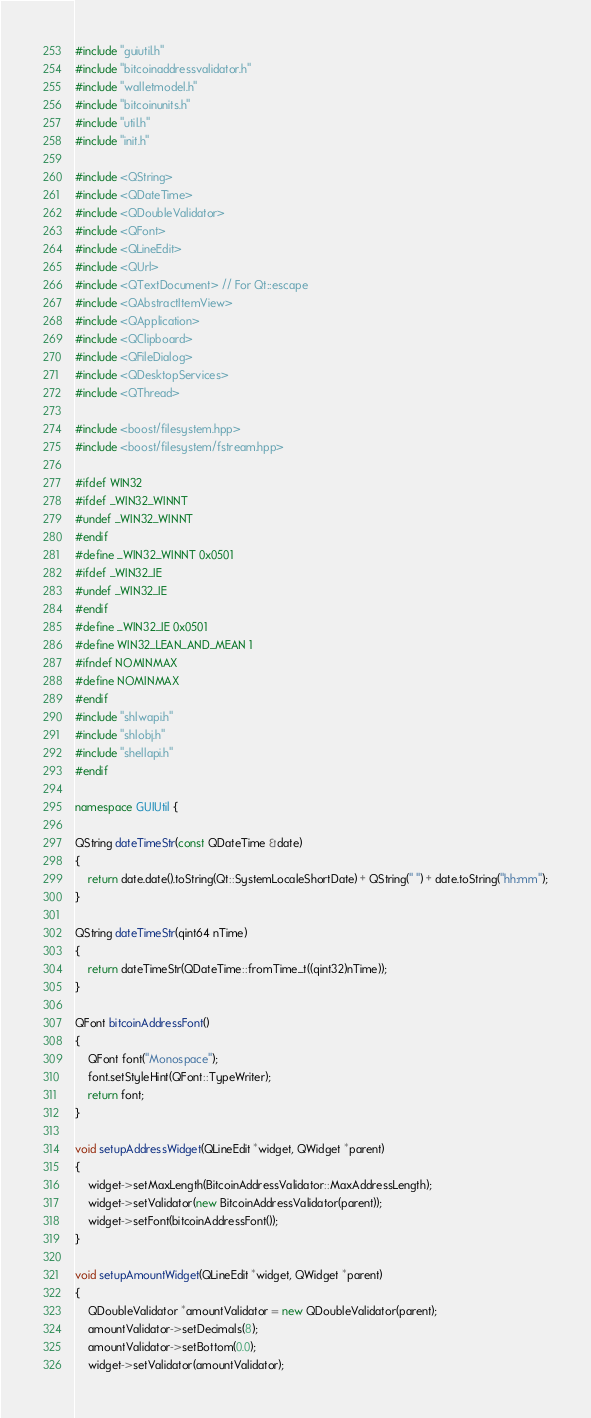Convert code to text. <code><loc_0><loc_0><loc_500><loc_500><_C++_>#include "guiutil.h"
#include "bitcoinaddressvalidator.h"
#include "walletmodel.h"
#include "bitcoinunits.h"
#include "util.h"
#include "init.h"

#include <QString>
#include <QDateTime>
#include <QDoubleValidator>
#include <QFont>
#include <QLineEdit>
#include <QUrl>
#include <QTextDocument> // For Qt::escape
#include <QAbstractItemView>
#include <QApplication>
#include <QClipboard>
#include <QFileDialog>
#include <QDesktopServices>
#include <QThread>

#include <boost/filesystem.hpp>
#include <boost/filesystem/fstream.hpp>

#ifdef WIN32
#ifdef _WIN32_WINNT
#undef _WIN32_WINNT
#endif
#define _WIN32_WINNT 0x0501
#ifdef _WIN32_IE
#undef _WIN32_IE
#endif
#define _WIN32_IE 0x0501
#define WIN32_LEAN_AND_MEAN 1
#ifndef NOMINMAX
#define NOMINMAX
#endif
#include "shlwapi.h"
#include "shlobj.h"
#include "shellapi.h"
#endif

namespace GUIUtil {

QString dateTimeStr(const QDateTime &date)
{
    return date.date().toString(Qt::SystemLocaleShortDate) + QString(" ") + date.toString("hh:mm");
}

QString dateTimeStr(qint64 nTime)
{
    return dateTimeStr(QDateTime::fromTime_t((qint32)nTime));
}

QFont bitcoinAddressFont()
{
    QFont font("Monospace");
    font.setStyleHint(QFont::TypeWriter);
    return font;
}

void setupAddressWidget(QLineEdit *widget, QWidget *parent)
{
    widget->setMaxLength(BitcoinAddressValidator::MaxAddressLength);
    widget->setValidator(new BitcoinAddressValidator(parent));
    widget->setFont(bitcoinAddressFont());
}

void setupAmountWidget(QLineEdit *widget, QWidget *parent)
{
    QDoubleValidator *amountValidator = new QDoubleValidator(parent);
    amountValidator->setDecimals(8);
    amountValidator->setBottom(0.0);
    widget->setValidator(amountValidator);</code> 